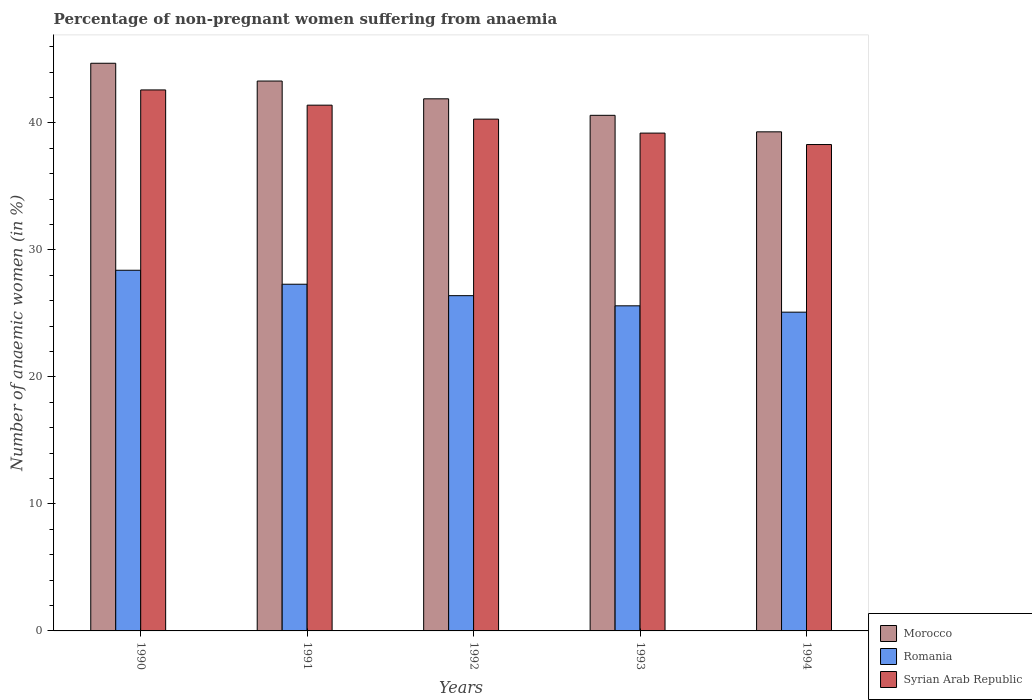How many groups of bars are there?
Provide a short and direct response. 5. What is the label of the 1st group of bars from the left?
Offer a terse response. 1990. In how many cases, is the number of bars for a given year not equal to the number of legend labels?
Give a very brief answer. 0. What is the percentage of non-pregnant women suffering from anaemia in Syrian Arab Republic in 1994?
Give a very brief answer. 38.3. Across all years, what is the maximum percentage of non-pregnant women suffering from anaemia in Syrian Arab Republic?
Keep it short and to the point. 42.6. Across all years, what is the minimum percentage of non-pregnant women suffering from anaemia in Romania?
Offer a very short reply. 25.1. In which year was the percentage of non-pregnant women suffering from anaemia in Syrian Arab Republic minimum?
Give a very brief answer. 1994. What is the total percentage of non-pregnant women suffering from anaemia in Romania in the graph?
Your answer should be very brief. 132.8. What is the difference between the percentage of non-pregnant women suffering from anaemia in Morocco in 1990 and that in 1993?
Ensure brevity in your answer.  4.1. What is the difference between the percentage of non-pregnant women suffering from anaemia in Syrian Arab Republic in 1992 and the percentage of non-pregnant women suffering from anaemia in Romania in 1993?
Your answer should be compact. 14.7. What is the average percentage of non-pregnant women suffering from anaemia in Morocco per year?
Offer a very short reply. 41.96. In the year 1994, what is the difference between the percentage of non-pregnant women suffering from anaemia in Romania and percentage of non-pregnant women suffering from anaemia in Morocco?
Your response must be concise. -14.2. In how many years, is the percentage of non-pregnant women suffering from anaemia in Morocco greater than 2 %?
Offer a terse response. 5. What is the ratio of the percentage of non-pregnant women suffering from anaemia in Romania in 1992 to that in 1993?
Provide a succinct answer. 1.03. Is the percentage of non-pregnant women suffering from anaemia in Morocco in 1992 less than that in 1993?
Provide a short and direct response. No. Is the difference between the percentage of non-pregnant women suffering from anaemia in Romania in 1993 and 1994 greater than the difference between the percentage of non-pregnant women suffering from anaemia in Morocco in 1993 and 1994?
Offer a very short reply. No. What is the difference between the highest and the second highest percentage of non-pregnant women suffering from anaemia in Morocco?
Give a very brief answer. 1.4. What is the difference between the highest and the lowest percentage of non-pregnant women suffering from anaemia in Morocco?
Keep it short and to the point. 5.4. Is the sum of the percentage of non-pregnant women suffering from anaemia in Romania in 1991 and 1993 greater than the maximum percentage of non-pregnant women suffering from anaemia in Syrian Arab Republic across all years?
Offer a terse response. Yes. What does the 2nd bar from the left in 1991 represents?
Your answer should be compact. Romania. What does the 2nd bar from the right in 1993 represents?
Offer a very short reply. Romania. Is it the case that in every year, the sum of the percentage of non-pregnant women suffering from anaemia in Morocco and percentage of non-pregnant women suffering from anaemia in Syrian Arab Republic is greater than the percentage of non-pregnant women suffering from anaemia in Romania?
Your response must be concise. Yes. Are all the bars in the graph horizontal?
Provide a short and direct response. No. Are the values on the major ticks of Y-axis written in scientific E-notation?
Make the answer very short. No. Does the graph contain any zero values?
Give a very brief answer. No. How many legend labels are there?
Your response must be concise. 3. How are the legend labels stacked?
Offer a very short reply. Vertical. What is the title of the graph?
Provide a succinct answer. Percentage of non-pregnant women suffering from anaemia. Does "Least developed countries" appear as one of the legend labels in the graph?
Keep it short and to the point. No. What is the label or title of the X-axis?
Provide a succinct answer. Years. What is the label or title of the Y-axis?
Your answer should be very brief. Number of anaemic women (in %). What is the Number of anaemic women (in %) of Morocco in 1990?
Your response must be concise. 44.7. What is the Number of anaemic women (in %) of Romania in 1990?
Give a very brief answer. 28.4. What is the Number of anaemic women (in %) in Syrian Arab Republic in 1990?
Make the answer very short. 42.6. What is the Number of anaemic women (in %) of Morocco in 1991?
Offer a terse response. 43.3. What is the Number of anaemic women (in %) of Romania in 1991?
Make the answer very short. 27.3. What is the Number of anaemic women (in %) in Syrian Arab Republic in 1991?
Provide a short and direct response. 41.4. What is the Number of anaemic women (in %) in Morocco in 1992?
Your response must be concise. 41.9. What is the Number of anaemic women (in %) of Romania in 1992?
Offer a terse response. 26.4. What is the Number of anaemic women (in %) in Syrian Arab Republic in 1992?
Your answer should be very brief. 40.3. What is the Number of anaemic women (in %) of Morocco in 1993?
Give a very brief answer. 40.6. What is the Number of anaemic women (in %) of Romania in 1993?
Your answer should be compact. 25.6. What is the Number of anaemic women (in %) in Syrian Arab Republic in 1993?
Give a very brief answer. 39.2. What is the Number of anaemic women (in %) in Morocco in 1994?
Offer a terse response. 39.3. What is the Number of anaemic women (in %) of Romania in 1994?
Your answer should be compact. 25.1. What is the Number of anaemic women (in %) of Syrian Arab Republic in 1994?
Your answer should be very brief. 38.3. Across all years, what is the maximum Number of anaemic women (in %) in Morocco?
Your response must be concise. 44.7. Across all years, what is the maximum Number of anaemic women (in %) of Romania?
Provide a short and direct response. 28.4. Across all years, what is the maximum Number of anaemic women (in %) in Syrian Arab Republic?
Make the answer very short. 42.6. Across all years, what is the minimum Number of anaemic women (in %) of Morocco?
Offer a terse response. 39.3. Across all years, what is the minimum Number of anaemic women (in %) in Romania?
Make the answer very short. 25.1. Across all years, what is the minimum Number of anaemic women (in %) of Syrian Arab Republic?
Make the answer very short. 38.3. What is the total Number of anaemic women (in %) of Morocco in the graph?
Your answer should be very brief. 209.8. What is the total Number of anaemic women (in %) in Romania in the graph?
Keep it short and to the point. 132.8. What is the total Number of anaemic women (in %) of Syrian Arab Republic in the graph?
Make the answer very short. 201.8. What is the difference between the Number of anaemic women (in %) in Morocco in 1990 and that in 1991?
Your response must be concise. 1.4. What is the difference between the Number of anaemic women (in %) of Syrian Arab Republic in 1990 and that in 1991?
Ensure brevity in your answer.  1.2. What is the difference between the Number of anaemic women (in %) in Romania in 1990 and that in 1992?
Ensure brevity in your answer.  2. What is the difference between the Number of anaemic women (in %) in Morocco in 1990 and that in 1993?
Offer a terse response. 4.1. What is the difference between the Number of anaemic women (in %) in Romania in 1990 and that in 1993?
Keep it short and to the point. 2.8. What is the difference between the Number of anaemic women (in %) in Romania in 1990 and that in 1994?
Provide a succinct answer. 3.3. What is the difference between the Number of anaemic women (in %) in Syrian Arab Republic in 1990 and that in 1994?
Make the answer very short. 4.3. What is the difference between the Number of anaemic women (in %) of Morocco in 1991 and that in 1992?
Provide a short and direct response. 1.4. What is the difference between the Number of anaemic women (in %) of Romania in 1991 and that in 1993?
Provide a succinct answer. 1.7. What is the difference between the Number of anaemic women (in %) in Syrian Arab Republic in 1991 and that in 1993?
Offer a terse response. 2.2. What is the difference between the Number of anaemic women (in %) in Morocco in 1992 and that in 1993?
Give a very brief answer. 1.3. What is the difference between the Number of anaemic women (in %) of Morocco in 1992 and that in 1994?
Your answer should be very brief. 2.6. What is the difference between the Number of anaemic women (in %) in Syrian Arab Republic in 1993 and that in 1994?
Provide a succinct answer. 0.9. What is the difference between the Number of anaemic women (in %) of Morocco in 1990 and the Number of anaemic women (in %) of Syrian Arab Republic in 1991?
Your answer should be very brief. 3.3. What is the difference between the Number of anaemic women (in %) in Romania in 1990 and the Number of anaemic women (in %) in Syrian Arab Republic in 1991?
Offer a terse response. -13. What is the difference between the Number of anaemic women (in %) of Morocco in 1990 and the Number of anaemic women (in %) of Romania in 1992?
Make the answer very short. 18.3. What is the difference between the Number of anaemic women (in %) of Romania in 1990 and the Number of anaemic women (in %) of Syrian Arab Republic in 1992?
Give a very brief answer. -11.9. What is the difference between the Number of anaemic women (in %) in Romania in 1990 and the Number of anaemic women (in %) in Syrian Arab Republic in 1993?
Keep it short and to the point. -10.8. What is the difference between the Number of anaemic women (in %) of Morocco in 1990 and the Number of anaemic women (in %) of Romania in 1994?
Give a very brief answer. 19.6. What is the difference between the Number of anaemic women (in %) of Romania in 1990 and the Number of anaemic women (in %) of Syrian Arab Republic in 1994?
Provide a short and direct response. -9.9. What is the difference between the Number of anaemic women (in %) of Morocco in 1991 and the Number of anaemic women (in %) of Romania in 1992?
Offer a terse response. 16.9. What is the difference between the Number of anaemic women (in %) of Romania in 1991 and the Number of anaemic women (in %) of Syrian Arab Republic in 1993?
Provide a succinct answer. -11.9. What is the difference between the Number of anaemic women (in %) in Morocco in 1992 and the Number of anaemic women (in %) in Syrian Arab Republic in 1993?
Give a very brief answer. 2.7. What is the difference between the Number of anaemic women (in %) in Romania in 1992 and the Number of anaemic women (in %) in Syrian Arab Republic in 1993?
Keep it short and to the point. -12.8. What is the difference between the Number of anaemic women (in %) of Morocco in 1993 and the Number of anaemic women (in %) of Romania in 1994?
Give a very brief answer. 15.5. What is the difference between the Number of anaemic women (in %) in Morocco in 1993 and the Number of anaemic women (in %) in Syrian Arab Republic in 1994?
Ensure brevity in your answer.  2.3. What is the difference between the Number of anaemic women (in %) of Romania in 1993 and the Number of anaemic women (in %) of Syrian Arab Republic in 1994?
Give a very brief answer. -12.7. What is the average Number of anaemic women (in %) of Morocco per year?
Offer a very short reply. 41.96. What is the average Number of anaemic women (in %) of Romania per year?
Offer a terse response. 26.56. What is the average Number of anaemic women (in %) in Syrian Arab Republic per year?
Your answer should be compact. 40.36. In the year 1990, what is the difference between the Number of anaemic women (in %) in Morocco and Number of anaemic women (in %) in Syrian Arab Republic?
Offer a very short reply. 2.1. In the year 1990, what is the difference between the Number of anaemic women (in %) of Romania and Number of anaemic women (in %) of Syrian Arab Republic?
Your response must be concise. -14.2. In the year 1991, what is the difference between the Number of anaemic women (in %) in Morocco and Number of anaemic women (in %) in Syrian Arab Republic?
Make the answer very short. 1.9. In the year 1991, what is the difference between the Number of anaemic women (in %) of Romania and Number of anaemic women (in %) of Syrian Arab Republic?
Your response must be concise. -14.1. In the year 1992, what is the difference between the Number of anaemic women (in %) of Romania and Number of anaemic women (in %) of Syrian Arab Republic?
Offer a very short reply. -13.9. In the year 1993, what is the difference between the Number of anaemic women (in %) of Morocco and Number of anaemic women (in %) of Romania?
Your answer should be compact. 15. In the year 1993, what is the difference between the Number of anaemic women (in %) of Romania and Number of anaemic women (in %) of Syrian Arab Republic?
Offer a terse response. -13.6. In the year 1994, what is the difference between the Number of anaemic women (in %) in Morocco and Number of anaemic women (in %) in Romania?
Make the answer very short. 14.2. In the year 1994, what is the difference between the Number of anaemic women (in %) of Romania and Number of anaemic women (in %) of Syrian Arab Republic?
Provide a succinct answer. -13.2. What is the ratio of the Number of anaemic women (in %) in Morocco in 1990 to that in 1991?
Your response must be concise. 1.03. What is the ratio of the Number of anaemic women (in %) in Romania in 1990 to that in 1991?
Your answer should be compact. 1.04. What is the ratio of the Number of anaemic women (in %) of Morocco in 1990 to that in 1992?
Offer a very short reply. 1.07. What is the ratio of the Number of anaemic women (in %) in Romania in 1990 to that in 1992?
Ensure brevity in your answer.  1.08. What is the ratio of the Number of anaemic women (in %) of Syrian Arab Republic in 1990 to that in 1992?
Your answer should be compact. 1.06. What is the ratio of the Number of anaemic women (in %) of Morocco in 1990 to that in 1993?
Keep it short and to the point. 1.1. What is the ratio of the Number of anaemic women (in %) of Romania in 1990 to that in 1993?
Keep it short and to the point. 1.11. What is the ratio of the Number of anaemic women (in %) in Syrian Arab Republic in 1990 to that in 1993?
Ensure brevity in your answer.  1.09. What is the ratio of the Number of anaemic women (in %) of Morocco in 1990 to that in 1994?
Your answer should be very brief. 1.14. What is the ratio of the Number of anaemic women (in %) of Romania in 1990 to that in 1994?
Keep it short and to the point. 1.13. What is the ratio of the Number of anaemic women (in %) in Syrian Arab Republic in 1990 to that in 1994?
Provide a short and direct response. 1.11. What is the ratio of the Number of anaemic women (in %) in Morocco in 1991 to that in 1992?
Make the answer very short. 1.03. What is the ratio of the Number of anaemic women (in %) of Romania in 1991 to that in 1992?
Give a very brief answer. 1.03. What is the ratio of the Number of anaemic women (in %) of Syrian Arab Republic in 1991 to that in 1992?
Your response must be concise. 1.03. What is the ratio of the Number of anaemic women (in %) of Morocco in 1991 to that in 1993?
Offer a very short reply. 1.07. What is the ratio of the Number of anaemic women (in %) in Romania in 1991 to that in 1993?
Offer a very short reply. 1.07. What is the ratio of the Number of anaemic women (in %) of Syrian Arab Republic in 1991 to that in 1993?
Give a very brief answer. 1.06. What is the ratio of the Number of anaemic women (in %) in Morocco in 1991 to that in 1994?
Offer a terse response. 1.1. What is the ratio of the Number of anaemic women (in %) in Romania in 1991 to that in 1994?
Your response must be concise. 1.09. What is the ratio of the Number of anaemic women (in %) in Syrian Arab Republic in 1991 to that in 1994?
Offer a terse response. 1.08. What is the ratio of the Number of anaemic women (in %) in Morocco in 1992 to that in 1993?
Ensure brevity in your answer.  1.03. What is the ratio of the Number of anaemic women (in %) of Romania in 1992 to that in 1993?
Offer a very short reply. 1.03. What is the ratio of the Number of anaemic women (in %) of Syrian Arab Republic in 1992 to that in 1993?
Your answer should be very brief. 1.03. What is the ratio of the Number of anaemic women (in %) in Morocco in 1992 to that in 1994?
Provide a short and direct response. 1.07. What is the ratio of the Number of anaemic women (in %) in Romania in 1992 to that in 1994?
Your response must be concise. 1.05. What is the ratio of the Number of anaemic women (in %) in Syrian Arab Republic in 1992 to that in 1994?
Ensure brevity in your answer.  1.05. What is the ratio of the Number of anaemic women (in %) in Morocco in 1993 to that in 1994?
Give a very brief answer. 1.03. What is the ratio of the Number of anaemic women (in %) in Romania in 1993 to that in 1994?
Your response must be concise. 1.02. What is the ratio of the Number of anaemic women (in %) in Syrian Arab Republic in 1993 to that in 1994?
Your answer should be compact. 1.02. What is the difference between the highest and the second highest Number of anaemic women (in %) in Morocco?
Your response must be concise. 1.4. What is the difference between the highest and the second highest Number of anaemic women (in %) of Romania?
Ensure brevity in your answer.  1.1. What is the difference between the highest and the second highest Number of anaemic women (in %) of Syrian Arab Republic?
Give a very brief answer. 1.2. What is the difference between the highest and the lowest Number of anaemic women (in %) in Morocco?
Keep it short and to the point. 5.4. What is the difference between the highest and the lowest Number of anaemic women (in %) of Syrian Arab Republic?
Provide a short and direct response. 4.3. 